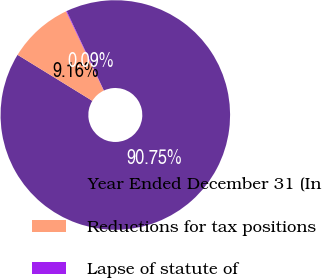Convert chart. <chart><loc_0><loc_0><loc_500><loc_500><pie_chart><fcel>Year Ended December 31 (In<fcel>Reductions for tax positions<fcel>Lapse of statute of<nl><fcel>90.75%<fcel>9.16%<fcel>0.09%<nl></chart> 